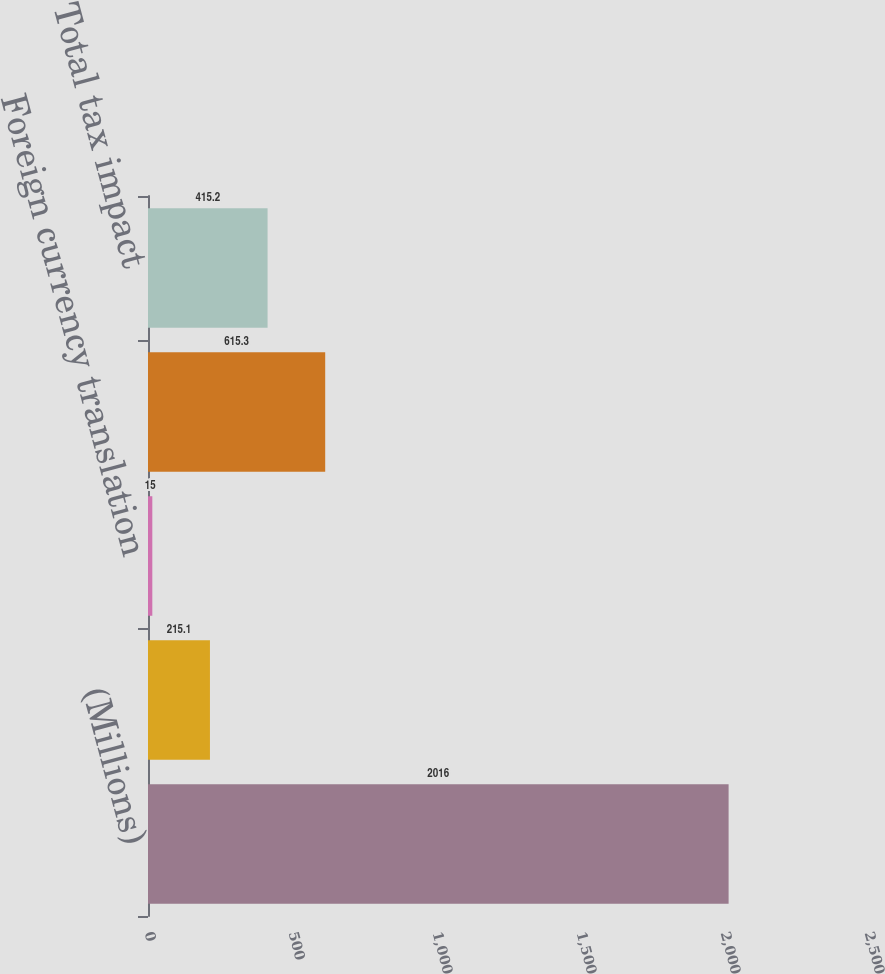<chart> <loc_0><loc_0><loc_500><loc_500><bar_chart><fcel>(Millions)<fcel>Investment securities<fcel>Foreign currency translation<fcel>Net investment hedges<fcel>Total tax impact<nl><fcel>2016<fcel>215.1<fcel>15<fcel>615.3<fcel>415.2<nl></chart> 